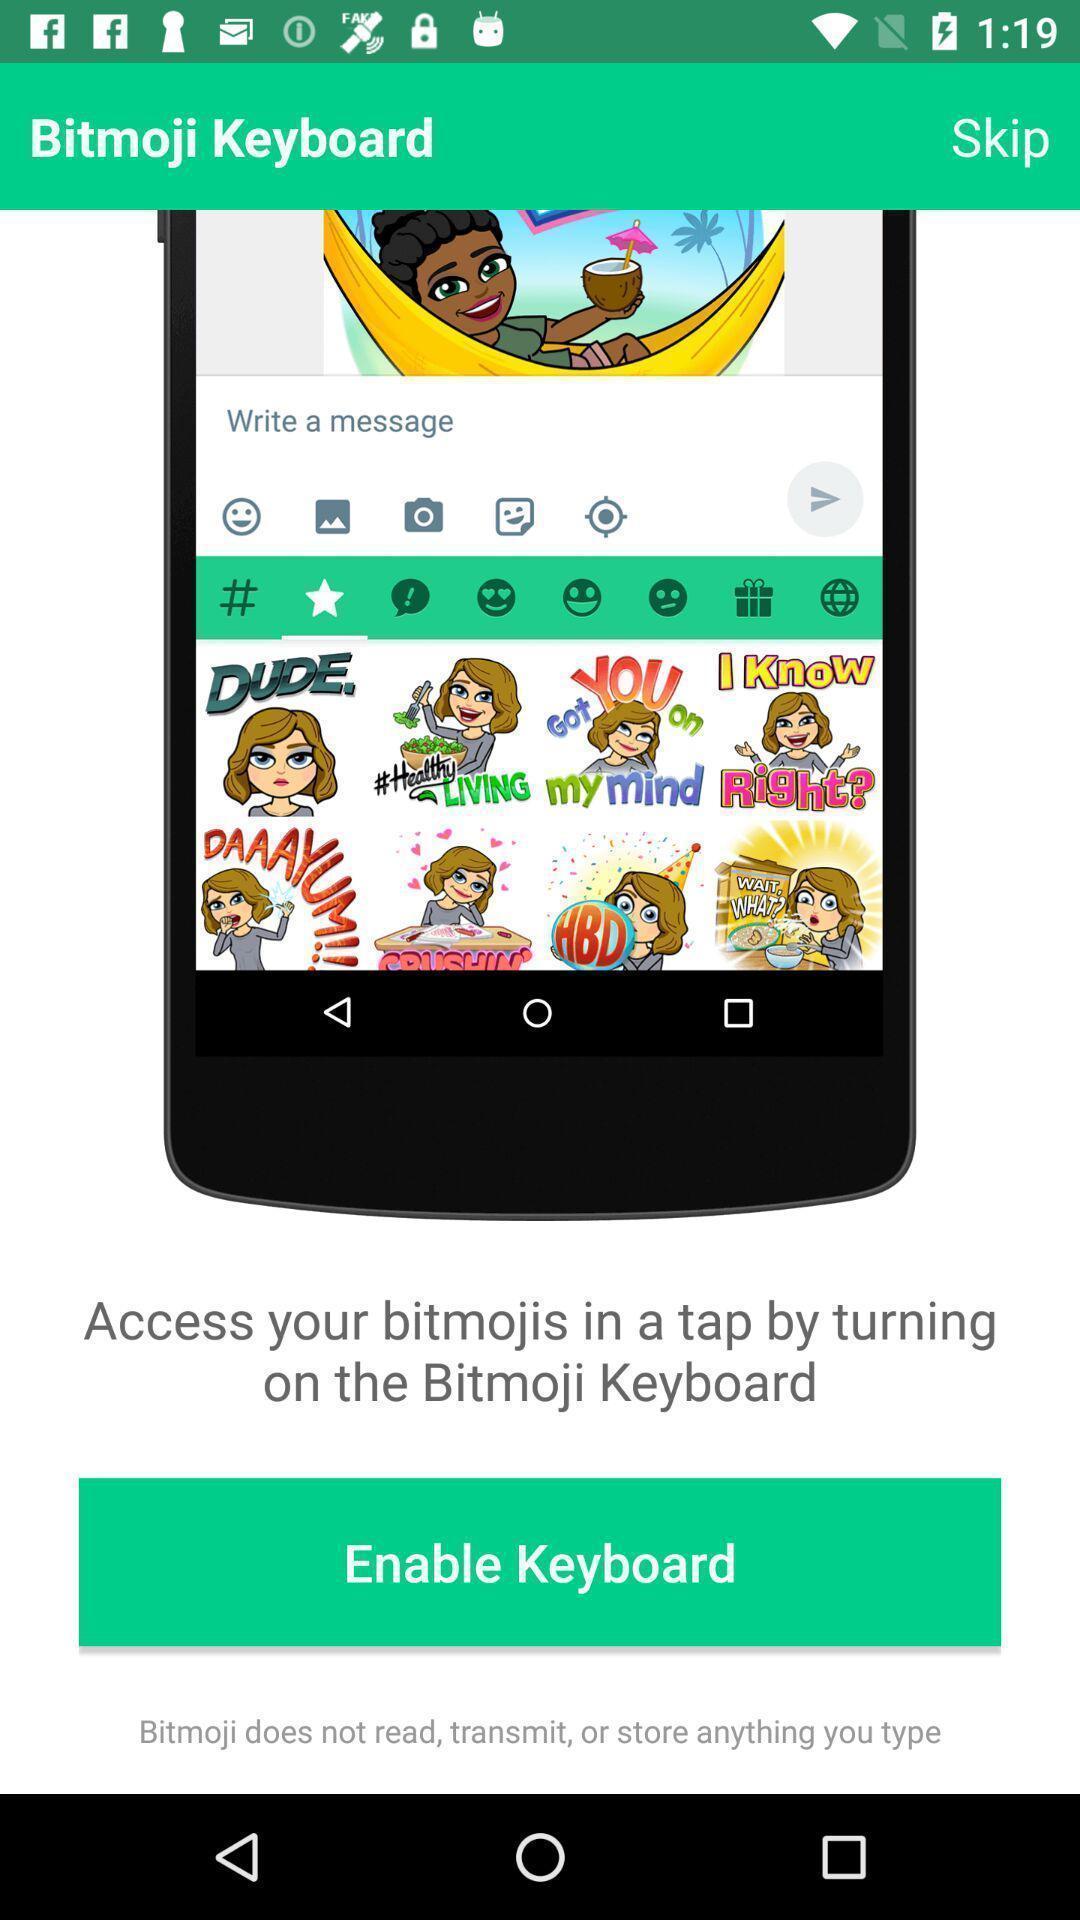Summarize the information in this screenshot. Welcome page displaying information about application with enable option. 